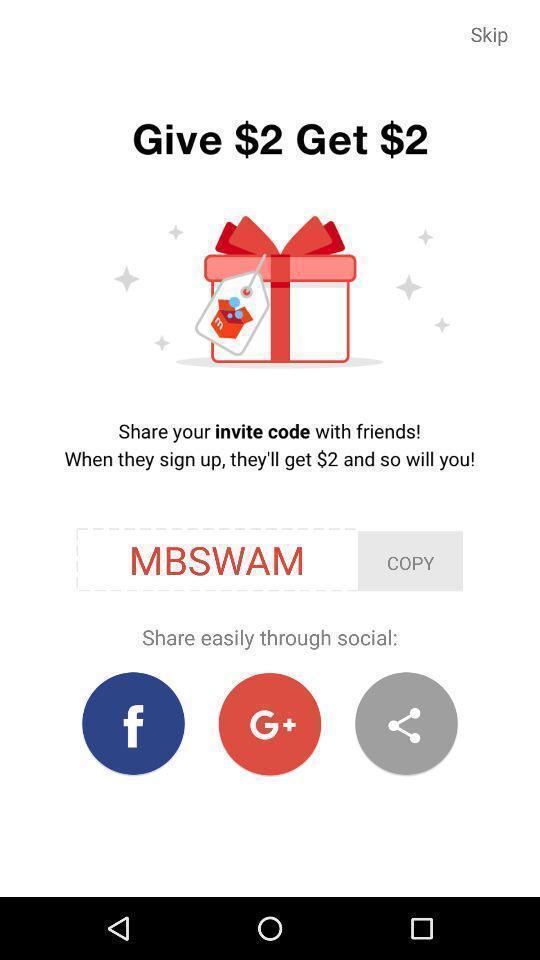Tell me what you see in this picture. Screen showing page with share option. 